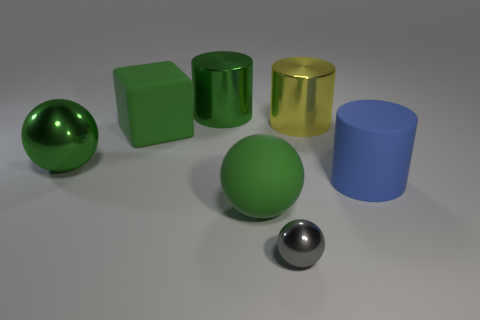What is the lighting like in this scene? The lighting in this scene appears soft and diffused, providing gentle illumination that casts subtle shadows, which suggests an overcast day or a setting with ample ambient light without harsh direct sources. 